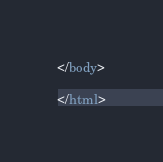Convert code to text. <code><loc_0><loc_0><loc_500><loc_500><_HTML_></body>

</html></code> 